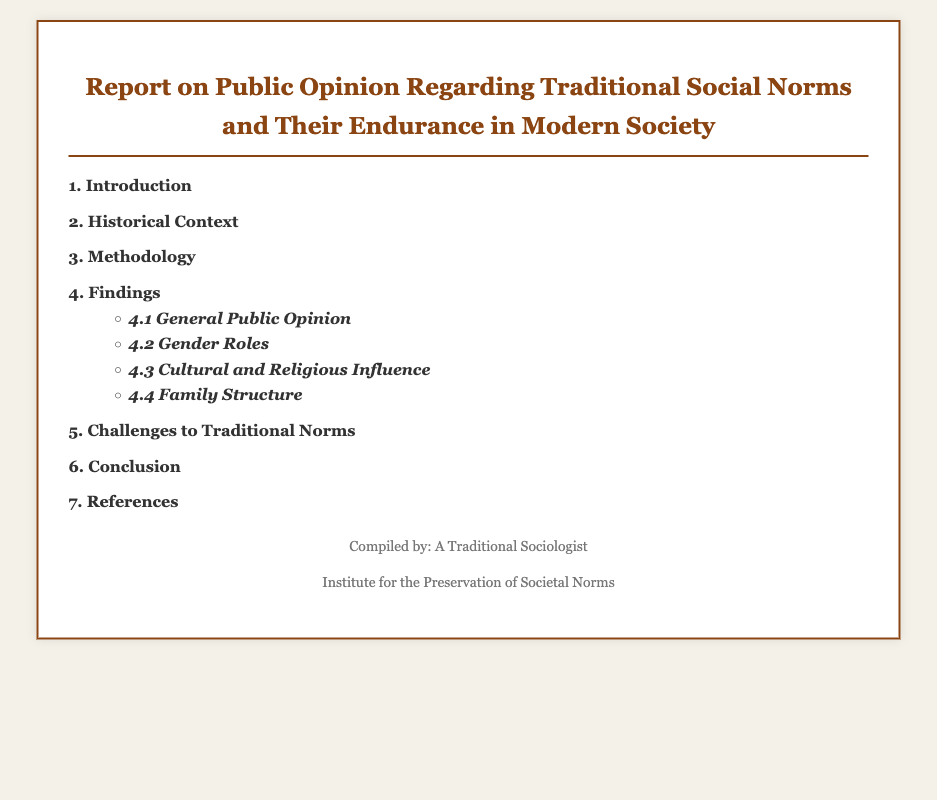What is the title of the report? The title can be found in the header section of the document, which prominently displays it.
Answer: Report on Public Opinion Regarding Traditional Social Norms and Their Endurance in Modern Society How many main sections are there in the index? The index lists each section with numbers, allowing us to count the sections easily.
Answer: 7 What does section 4 focus on? The index clearly outlines that section 4 is dedicated to a specific topic that is listed after the main section.
Answer: Findings What is emphasized in subsection 4.2? The subsection titles give specific aspects included in section 4, detailing its various focuses.
Answer: Gender Roles Who compiled the document? The footer provides information on the author, including the name of the traditional sociologist responsible for the compilation.
Answer: A Traditional Sociologist What is the purpose of the organization mentioned in the footer? By reviewing the footer, we can understand the mission or objective of the organization mentioned in relation to societal norms.
Answer: Preservation of Societal Norms 